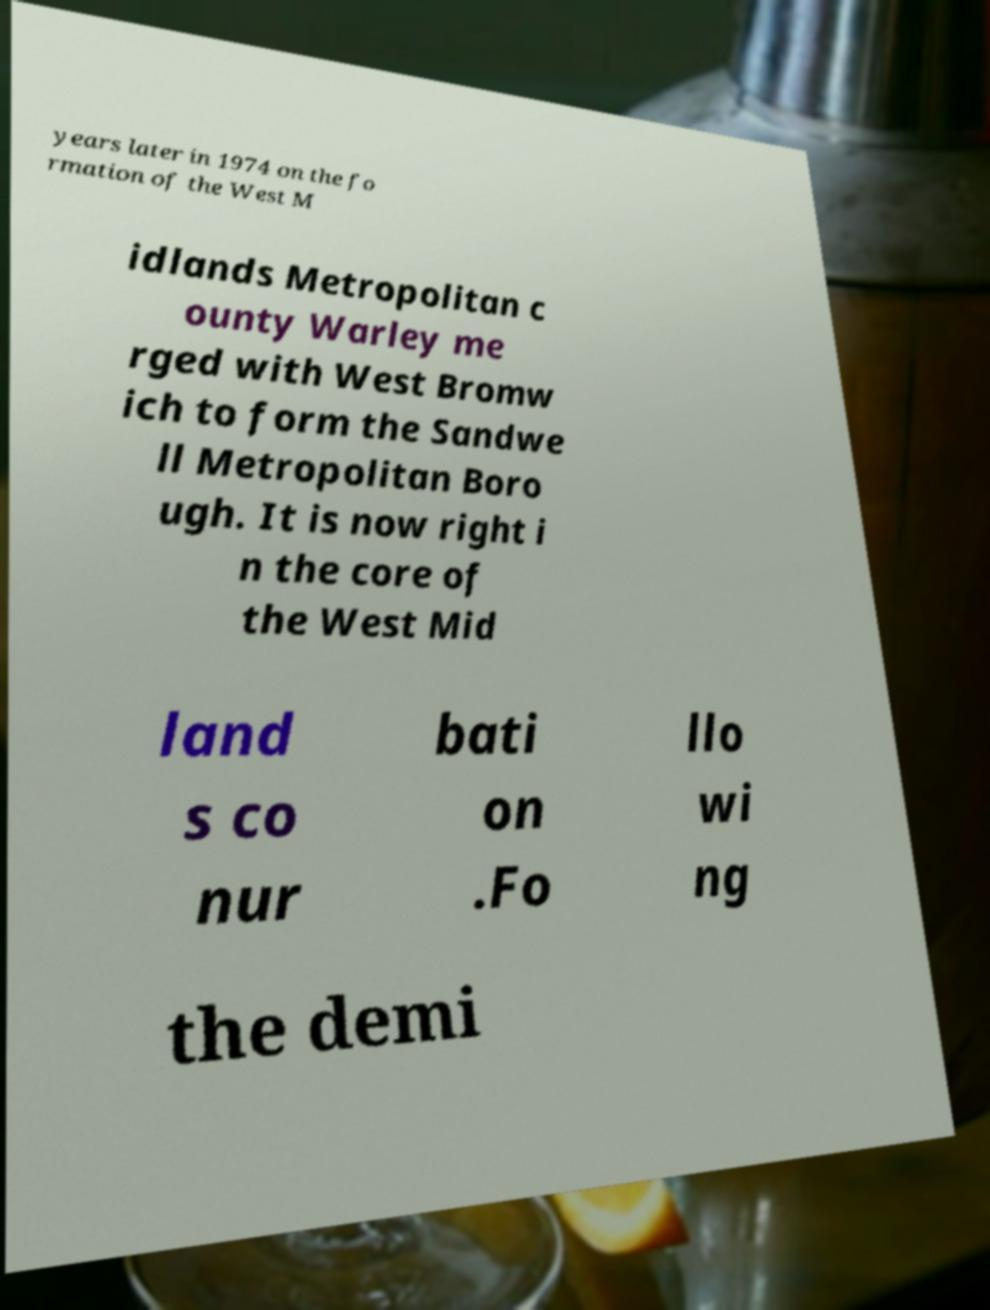For documentation purposes, I need the text within this image transcribed. Could you provide that? years later in 1974 on the fo rmation of the West M idlands Metropolitan c ounty Warley me rged with West Bromw ich to form the Sandwe ll Metropolitan Boro ugh. It is now right i n the core of the West Mid land s co nur bati on .Fo llo wi ng the demi 